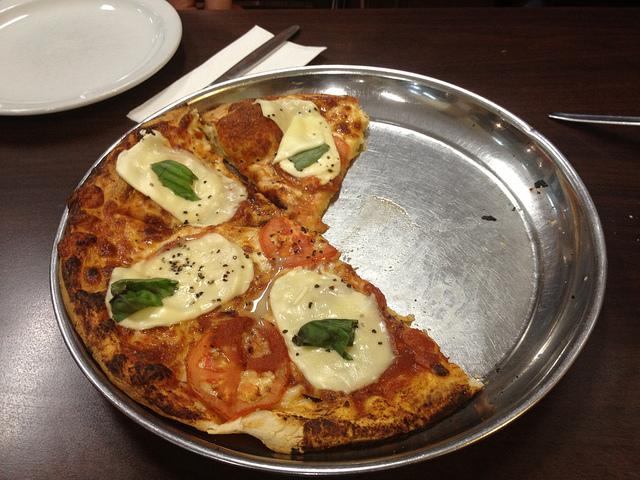What is the green stuff on top of the pizza?
Answer briefly. Spinach. What is the platter made of?
Give a very brief answer. Metal. How many slices are left?
Quick response, please. 4. Is this pizza fresh from the oven?
Give a very brief answer. No. 